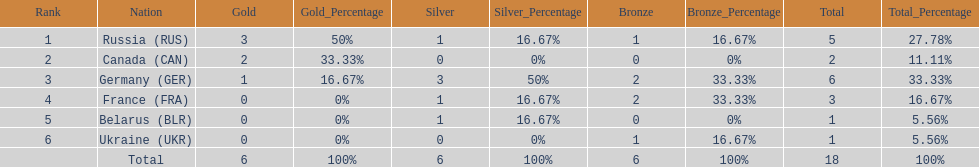Which country won more total medals than tue french, but less than the germans in the 1994 winter olympic biathlon? Russia. 